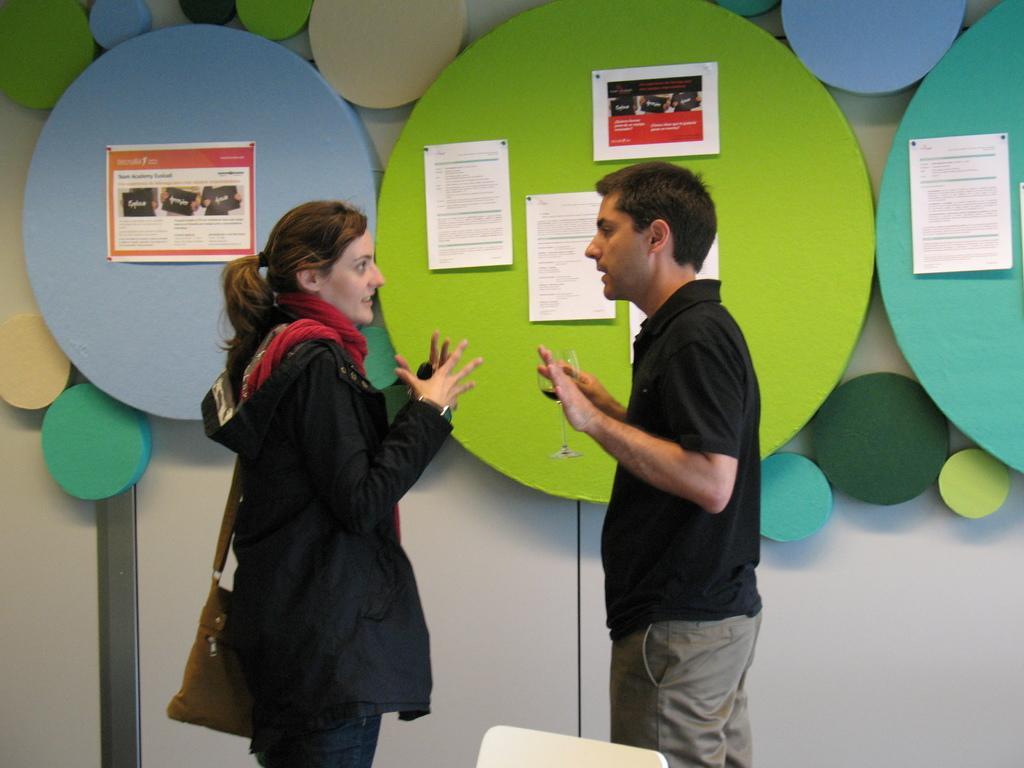Describe this image in one or two sentences. There are two people standing and talking, she is carrying a bag and this man holding a glass. In the background we can see colorful borders and we can see posters on these boards. 